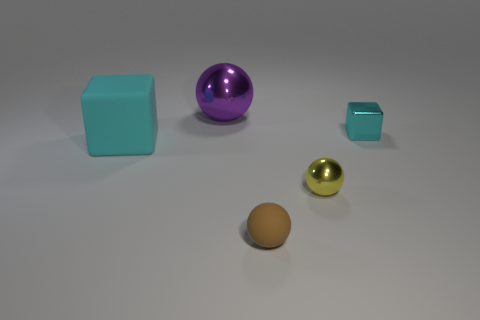Add 3 tiny cyan cylinders. How many objects exist? 8 Subtract all blocks. How many objects are left? 3 Add 4 yellow objects. How many yellow objects exist? 5 Subtract 0 blue spheres. How many objects are left? 5 Subtract all large brown matte things. Subtract all tiny brown matte things. How many objects are left? 4 Add 3 cyan matte blocks. How many cyan matte blocks are left? 4 